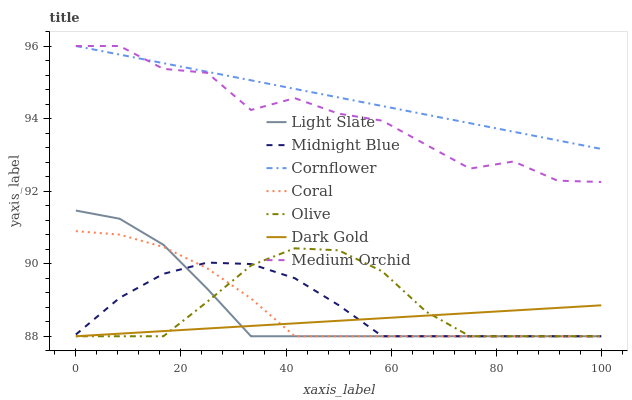Does Dark Gold have the minimum area under the curve?
Answer yes or no. Yes. Does Cornflower have the maximum area under the curve?
Answer yes or no. Yes. Does Midnight Blue have the minimum area under the curve?
Answer yes or no. No. Does Midnight Blue have the maximum area under the curve?
Answer yes or no. No. Is Dark Gold the smoothest?
Answer yes or no. Yes. Is Medium Orchid the roughest?
Answer yes or no. Yes. Is Midnight Blue the smoothest?
Answer yes or no. No. Is Midnight Blue the roughest?
Answer yes or no. No. Does Midnight Blue have the lowest value?
Answer yes or no. Yes. Does Medium Orchid have the lowest value?
Answer yes or no. No. Does Medium Orchid have the highest value?
Answer yes or no. Yes. Does Midnight Blue have the highest value?
Answer yes or no. No. Is Coral less than Medium Orchid?
Answer yes or no. Yes. Is Cornflower greater than Dark Gold?
Answer yes or no. Yes. Does Midnight Blue intersect Coral?
Answer yes or no. Yes. Is Midnight Blue less than Coral?
Answer yes or no. No. Is Midnight Blue greater than Coral?
Answer yes or no. No. Does Coral intersect Medium Orchid?
Answer yes or no. No. 